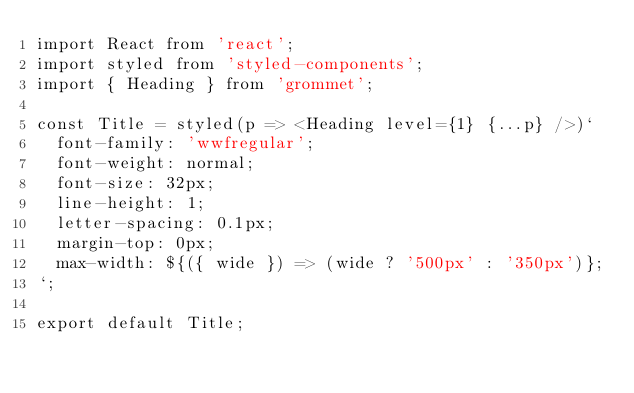<code> <loc_0><loc_0><loc_500><loc_500><_JavaScript_>import React from 'react';
import styled from 'styled-components';
import { Heading } from 'grommet';

const Title = styled(p => <Heading level={1} {...p} />)`
  font-family: 'wwfregular';
  font-weight: normal;
  font-size: 32px;
  line-height: 1;
  letter-spacing: 0.1px;
  margin-top: 0px;
  max-width: ${({ wide }) => (wide ? '500px' : '350px')};
`;

export default Title;
</code> 